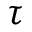Convert formula to latex. <formula><loc_0><loc_0><loc_500><loc_500>\tau</formula> 